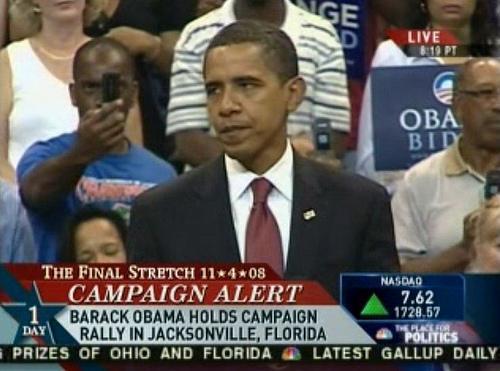How many people are visible?
Give a very brief answer. 9. 